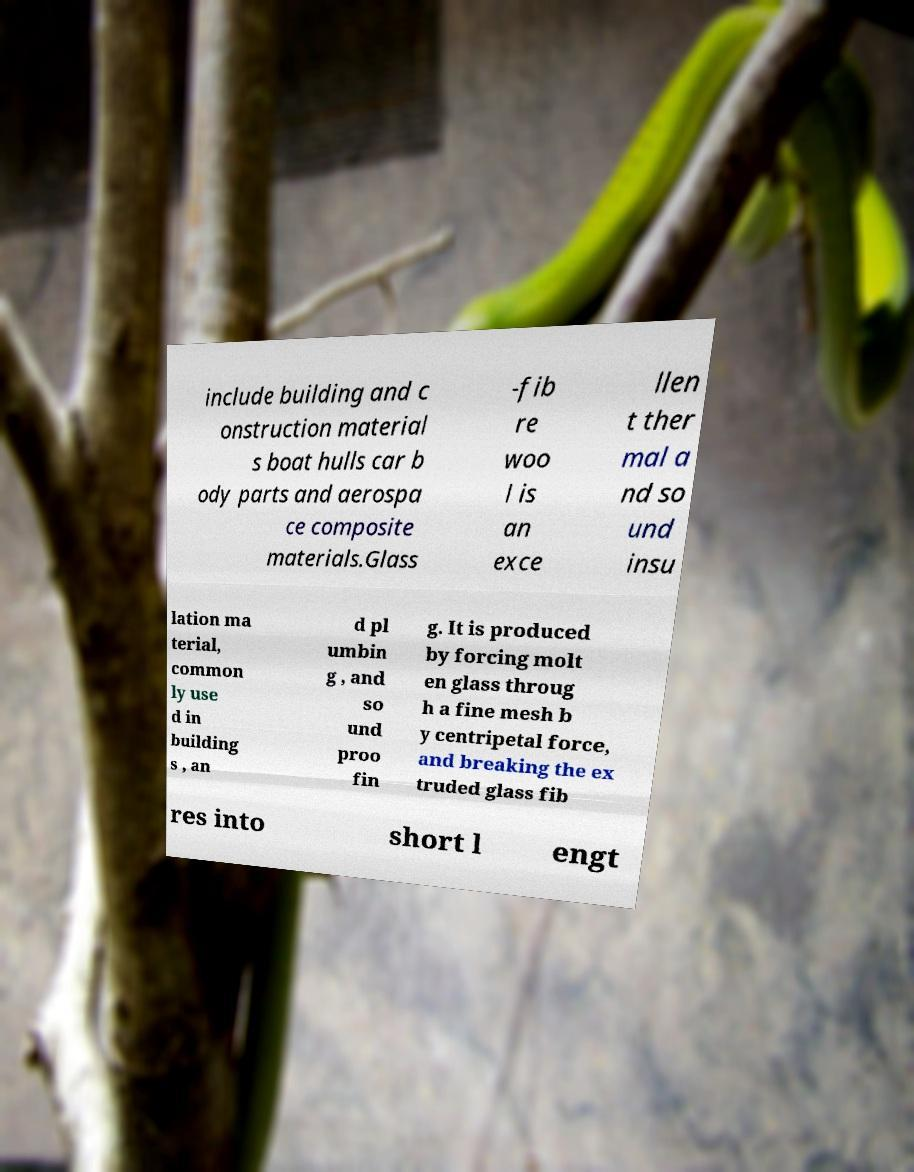Can you accurately transcribe the text from the provided image for me? include building and c onstruction material s boat hulls car b ody parts and aerospa ce composite materials.Glass -fib re woo l is an exce llen t ther mal a nd so und insu lation ma terial, common ly use d in building s , an d pl umbin g , and so und proo fin g. It is produced by forcing molt en glass throug h a fine mesh b y centripetal force, and breaking the ex truded glass fib res into short l engt 